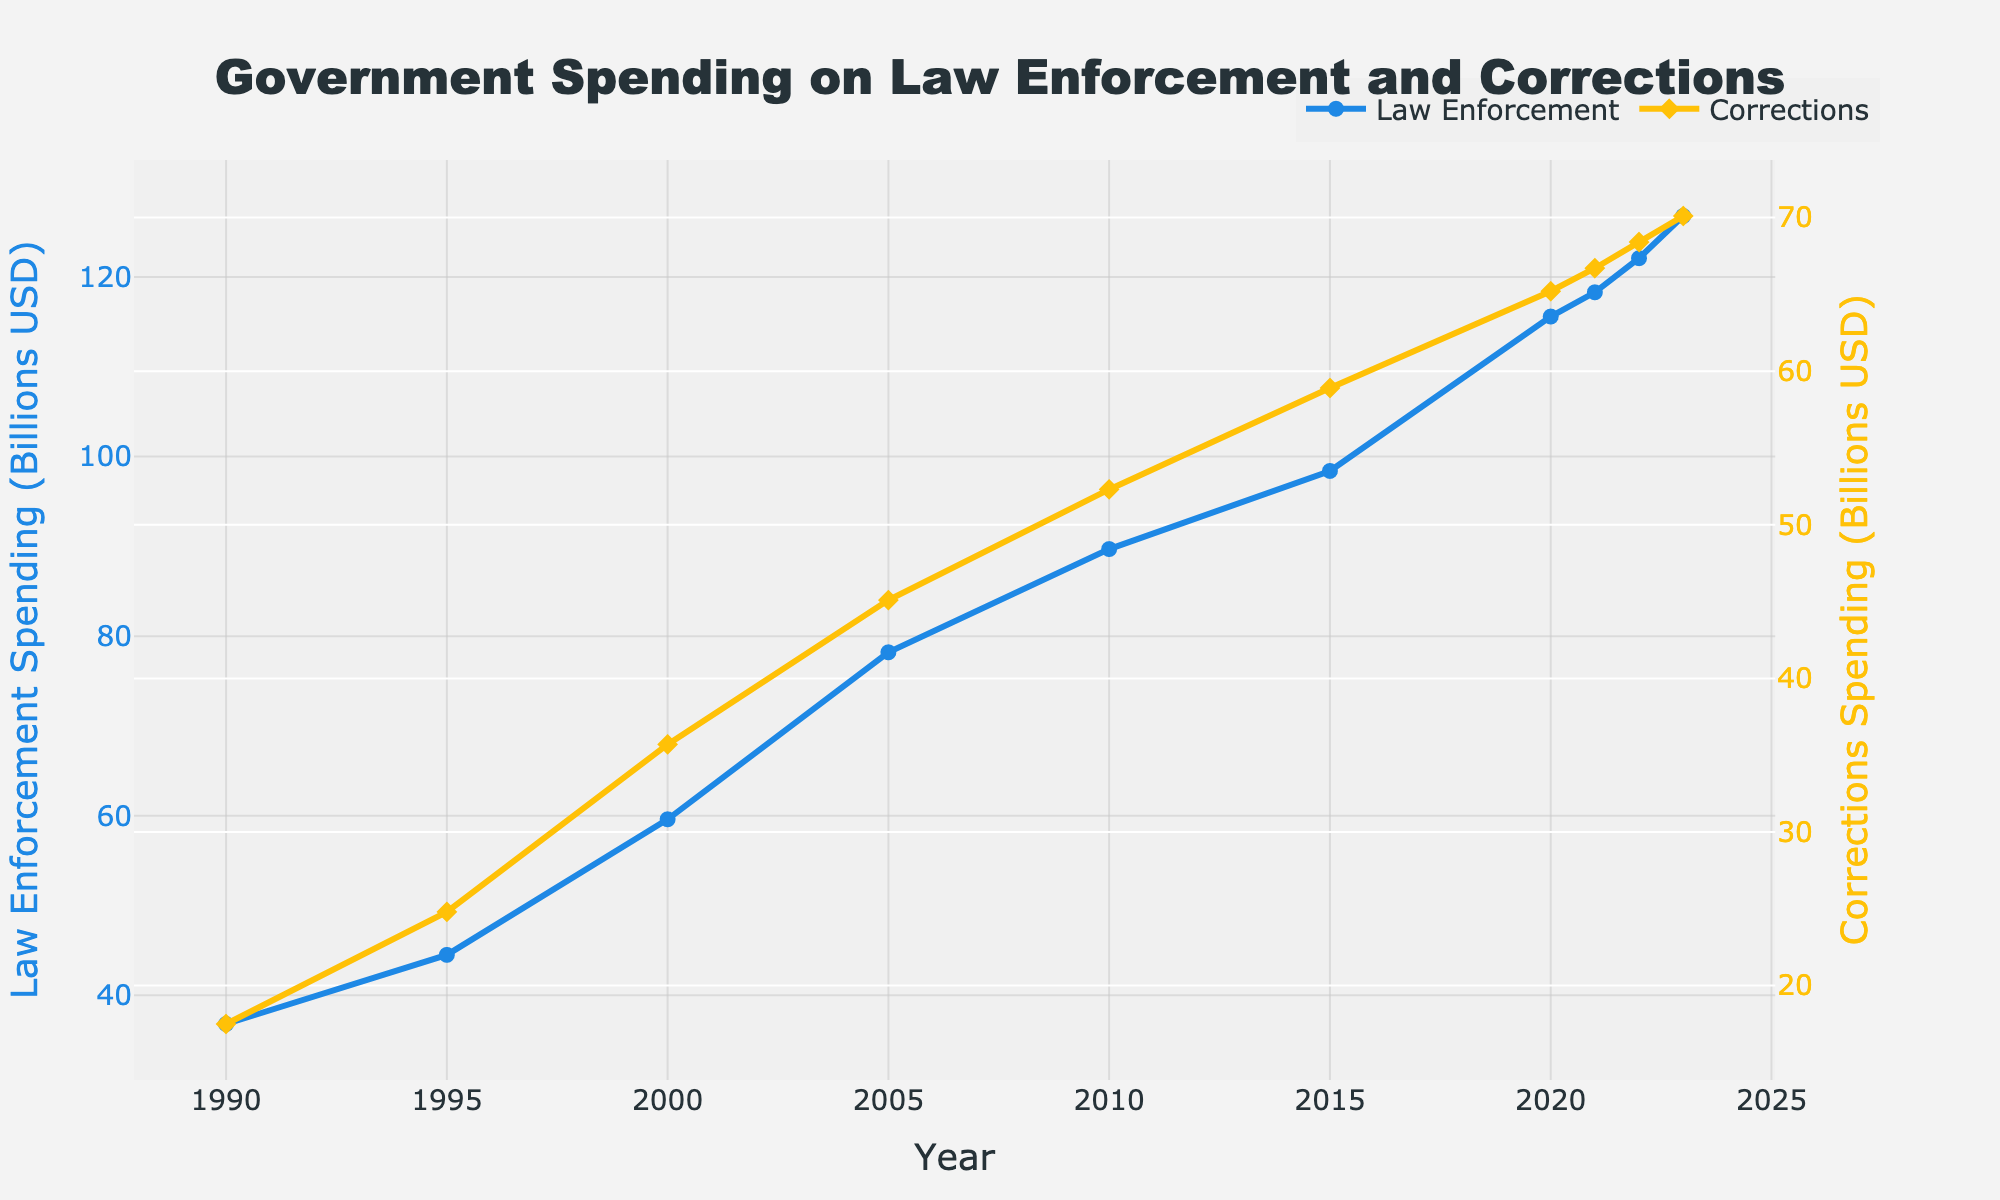What's the difference in Corrections Spending between 1990 and 2023? In 1990, the Corrections Spending was 17.5 billion USD, and in 2023, it was 70.1 billion USD. To find the difference, subtract the 1990 value from the 2023 value: 70.1 - 17.5 = 52.6 billion USD.
Answer: 52.6 billion USD How much did Law Enforcement Spending increase from 2000 to 2023? The Law Enforcement Spending in 2000 was 59.6 billion USD, and in 2023, it was 126.8 billion USD. To find the increase, subtract the 2000 value from the 2023 value: 126.8 - 59.6 = 67.2 billion USD.
Answer: 67.2 billion USD What is the median value of Law Enforcement Spending from 1990 to 2023? First, list the Law Enforcement Spending values in order: 36.8, 44.5, 59.6, 78.2, 89.7, 98.4, 115.6, 118.3, 122.1, 126.8. There are 10 values, so the median is the average of the 5th and 6th values: (89.7 + 98.4) / 2 = 94.05 billion USD.
Answer: 94.05 billion USD Which year showed a greater increase in Law Enforcement Spending compared to the previous year: 2015 or 2021? For 2015, the increase compared to 2010 is 98.4 - 89.7 = 8.7 billion USD. For 2021, the increase compared to 2020 is 118.3 - 115.6 = 2.7 billion USD. Since 8.7 billion USD is greater than 2.7 billion USD, 2015 showed a greater increase.
Answer: 2015 What is the average annual increase in Corrections Spending from 2010 to 2023? First, find the total increase in Corrections Spending from 2010 to 2023: 70.1 - 52.3 = 17.8 billion USD. There are 13 years between 2010 and 2023, so the average annual increase is 17.8 / 13 = approximately 1.37 billion USD per year.
Answer: 1.37 billion USD per year Which spending category, Law Enforcement or Corrections, had more substantial growth from 1990 to 2000? From 1990 to 2000, Law Enforcement Spending grew from 36.8 billion USD to 59.6 billion USD, an increase of 59.6 - 36.8 = 22.8 billion USD. Corrections Spending grew from 17.5 billion USD to 35.7 billion USD, an increase of 35.7 - 17.5 = 18.2 billion USD. Therefore, Law Enforcement had more substantial growth.
Answer: Law Enforcement Is the rate of increase in both Law Enforcement and Corrections Spending more substantial in the first half or the second half of the period (1990-2023)? For Law Enforcement: 1990-2005: 78.2 - 36.8 = 41.4 billion USD in 15 years. 2005-2023: 126.8 - 78.2 = 48.6 billion USD in 18 years. For Corrections: 1990-2005: 45.1 - 17.5 = 27.6 billion USD in 15 years. 2005-2023: 70.1 - 45.1 = 25 billion USD in 18 years. On average, for Law Enforcement, the second half has a higher total increase (though lower yearly, dividing by the number of years). For Corrections, the first half shows a more substantial rate of increase.
Answer: Law Enforcement: Second half, Corrections: First half Between which consecutive years did Corrections Spending show its highest increase? Calculating the increase for each consecutive pair of years: 1990-1995: 24.8 - 17.5 = 7.3 billion USD, 1995-2000: 35.7 - 24.8 = 10.9 billion USD, 2000-2005: 45.1 - 35.7 = 9.4 billion USD, 2005-2010: 52.3 - 45.1 = 7.2 billion USD, 2010-2015: 58.9 - 52.3 = 6.6 billion USD, 2015-2020: 65.2 - 58.9 = 6.3 billion USD, 2020-2021: 66.7 - 65.2 = 1.5 billion USD, 2021-2022: 68.4 - 66.7 = 1.7 billion USD, 2022-2023: 70.1 - 68.4 = 1.7 billion USD. The highest increase was between 1995 and 2000 (10.9 billion USD).
Answer: 1995-2000 What trend can be observed in Law Enforcement Spending and Corrections Spending over the years? Observing the trend from 1990 to 2023, both Law Enforcement Spending and Corrections Spending have shown a consistent increase over the years with no significant decreases, indicating a steady upward trend in government spending on both categories.
Answer: Steady upward trend 